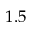Convert formula to latex. <formula><loc_0><loc_0><loc_500><loc_500>1 . 5</formula> 